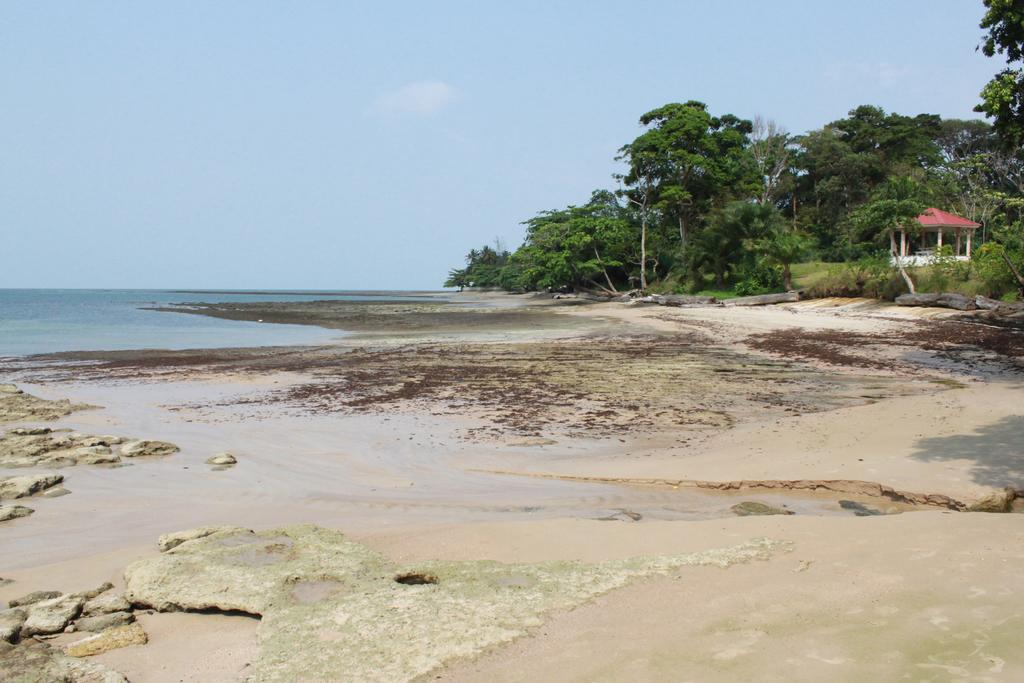What is in the foreground of the image? There is sand, stones, and water in the foreground of the image. What can be seen in the background of the image? There is a shelter, trees, and the sky visible in the background of the image. Can you describe the sky in the image? The sky is visible in the background of the image, and there is a cloud present. Is there any water visible in the background of the image? Yes, there is water visible in the background of the image. How many kites are flying in the image? There are no kites visible in the image. What type of insect can be seen crawling on the stones in the image? There are no insects present in the image. 